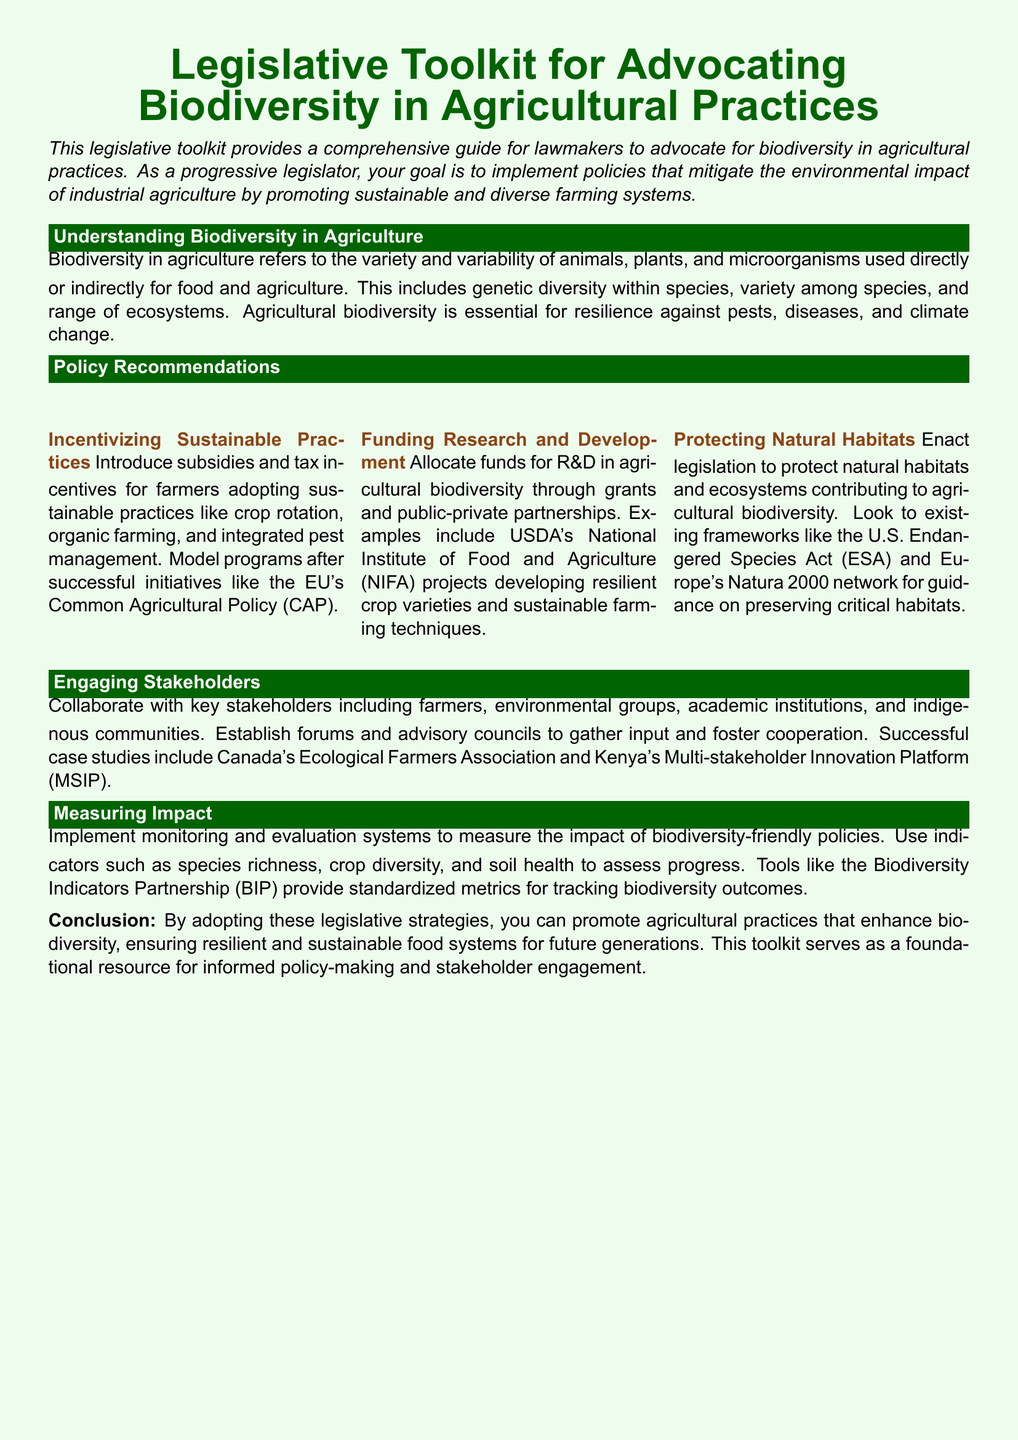What is the primary focus of the toolkit? The toolkit focuses on advocating for biodiversity in agricultural practices to mitigate the environmental impact of industrial agriculture.
Answer: Biodiversity in agricultural practices What are the three main policy recommendations? The three main policy recommendations are incentivizing sustainable practices, funding research and development, and protecting natural habitats.
Answer: Incentivizing sustainable practices, funding research and development, protecting natural habitats What does R&D stand for in the context of the toolkit? R&D stands for research and development, which is mentioned in the section regarding funding for agricultural biodiversity.
Answer: Research and development What is one example of a successful initiative mentioned for sustainable practices? The successful initiative mentioned is the EU's Common Agricultural Policy (CAP).
Answer: EU's Common Agricultural Policy (CAP) Which act is referenced in relation to protecting natural habitats? The U.S. Endangered Species Act (ESA) is referenced in relation to protecting natural habitats and ecosystems.
Answer: U.S. Endangered Species Act (ESA) What does the toolkit suggest to measure impact? The toolkit suggests implementing monitoring and evaluation systems with indicators like species richness and crop diversity to measure impact.
Answer: Monitoring and evaluation systems Which groups should stakeholders include according to the toolkit? Stakeholders should include farmers, environmental groups, academic institutions, and indigenous communities.
Answer: Farmers, environmental groups, academic institutions, indigenous communities What is the purpose of establishing forums and advisory councils? The purpose is to gather input and foster cooperation among stakeholders.
Answer: Gather input and foster cooperation What does the toolkit use from the Biodiversity Indicators Partnership? The toolkit uses standardized metrics for tracking biodiversity outcomes from the Biodiversity Indicators Partnership.
Answer: Standardized metrics for tracking biodiversity outcomes 